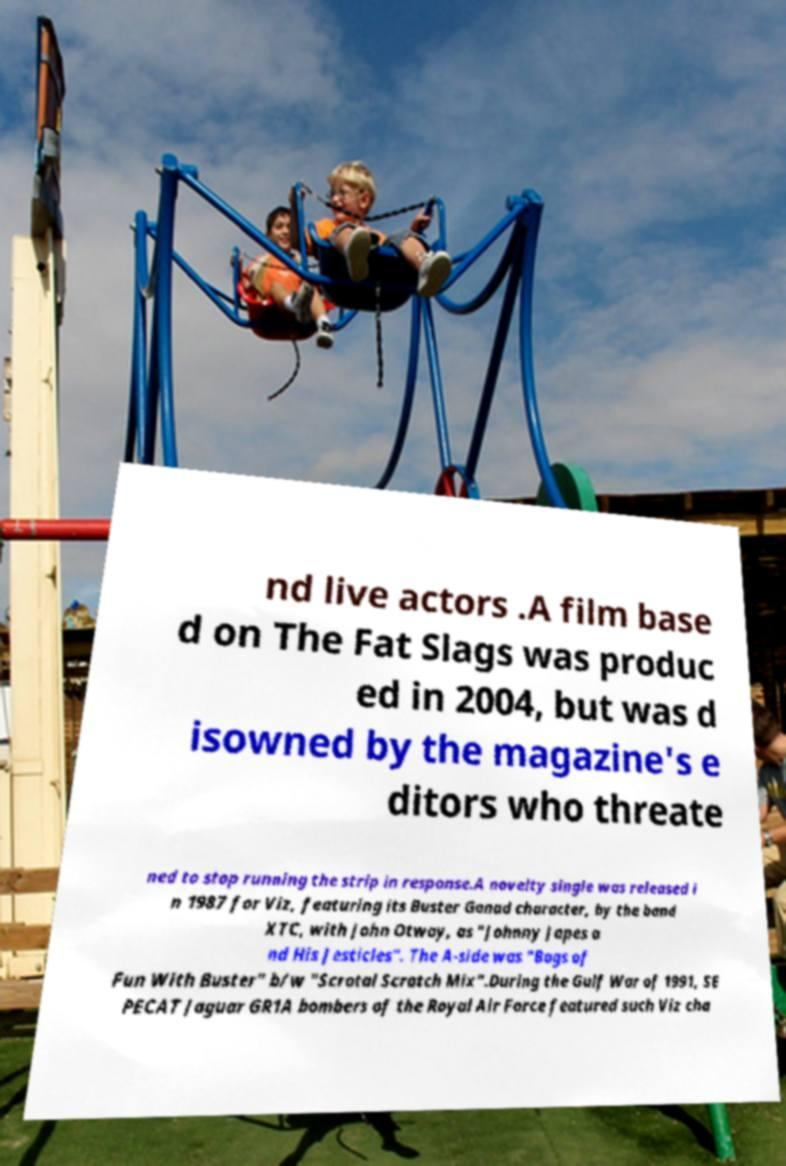What messages or text are displayed in this image? I need them in a readable, typed format. nd live actors .A film base d on The Fat Slags was produc ed in 2004, but was d isowned by the magazine's e ditors who threate ned to stop running the strip in response.A novelty single was released i n 1987 for Viz, featuring its Buster Gonad character, by the band XTC, with John Otway, as "Johnny Japes a nd His Jesticles". The A-side was "Bags of Fun With Buster" b/w "Scrotal Scratch Mix".During the Gulf War of 1991, SE PECAT Jaguar GR1A bombers of the Royal Air Force featured such Viz cha 